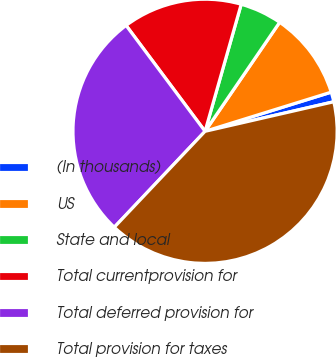Convert chart. <chart><loc_0><loc_0><loc_500><loc_500><pie_chart><fcel>(In thousands)<fcel>US<fcel>State and local<fcel>Total currentprovision for<fcel>Total deferred provision for<fcel>Total provision for taxes<nl><fcel>1.2%<fcel>10.66%<fcel>5.14%<fcel>14.61%<fcel>27.74%<fcel>40.65%<nl></chart> 